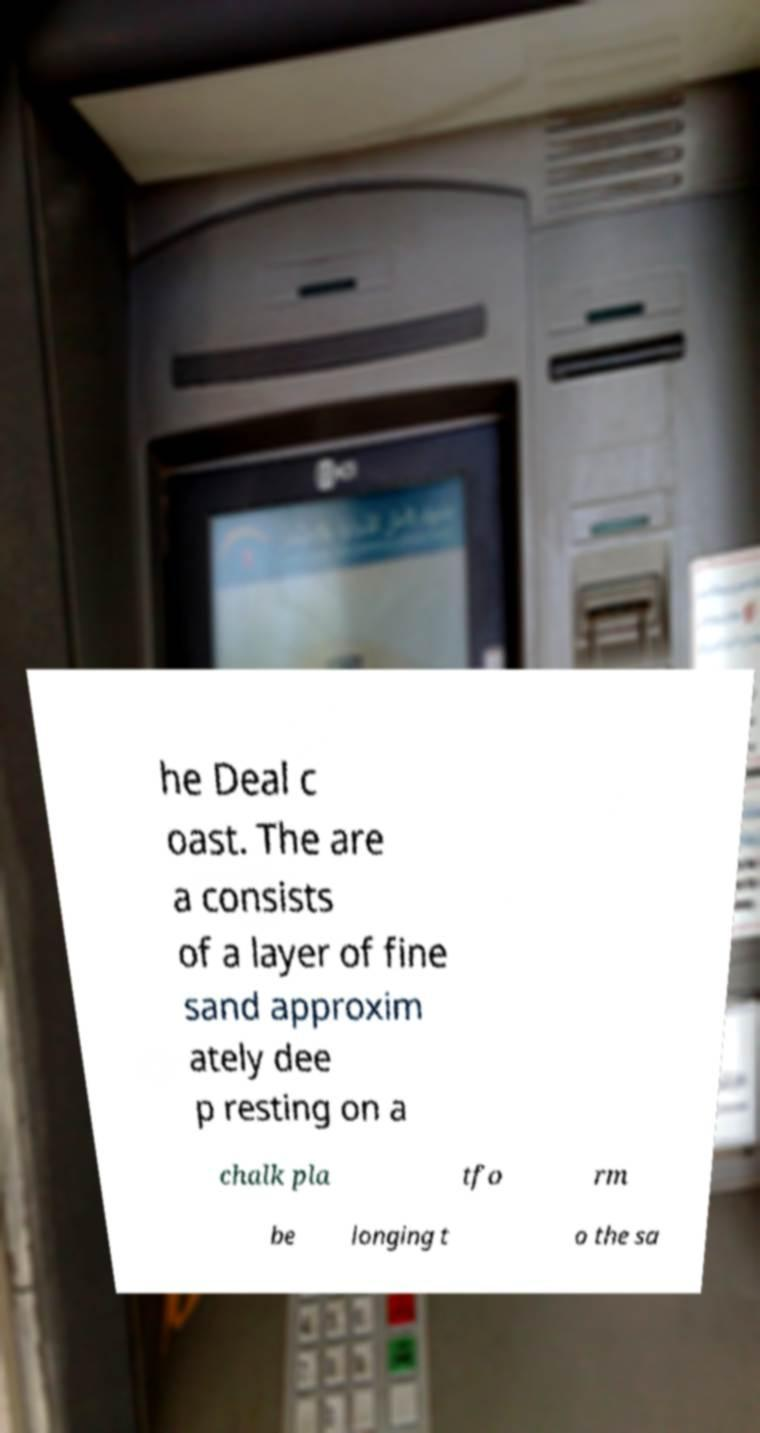Can you accurately transcribe the text from the provided image for me? he Deal c oast. The are a consists of a layer of fine sand approxim ately dee p resting on a chalk pla tfo rm be longing t o the sa 